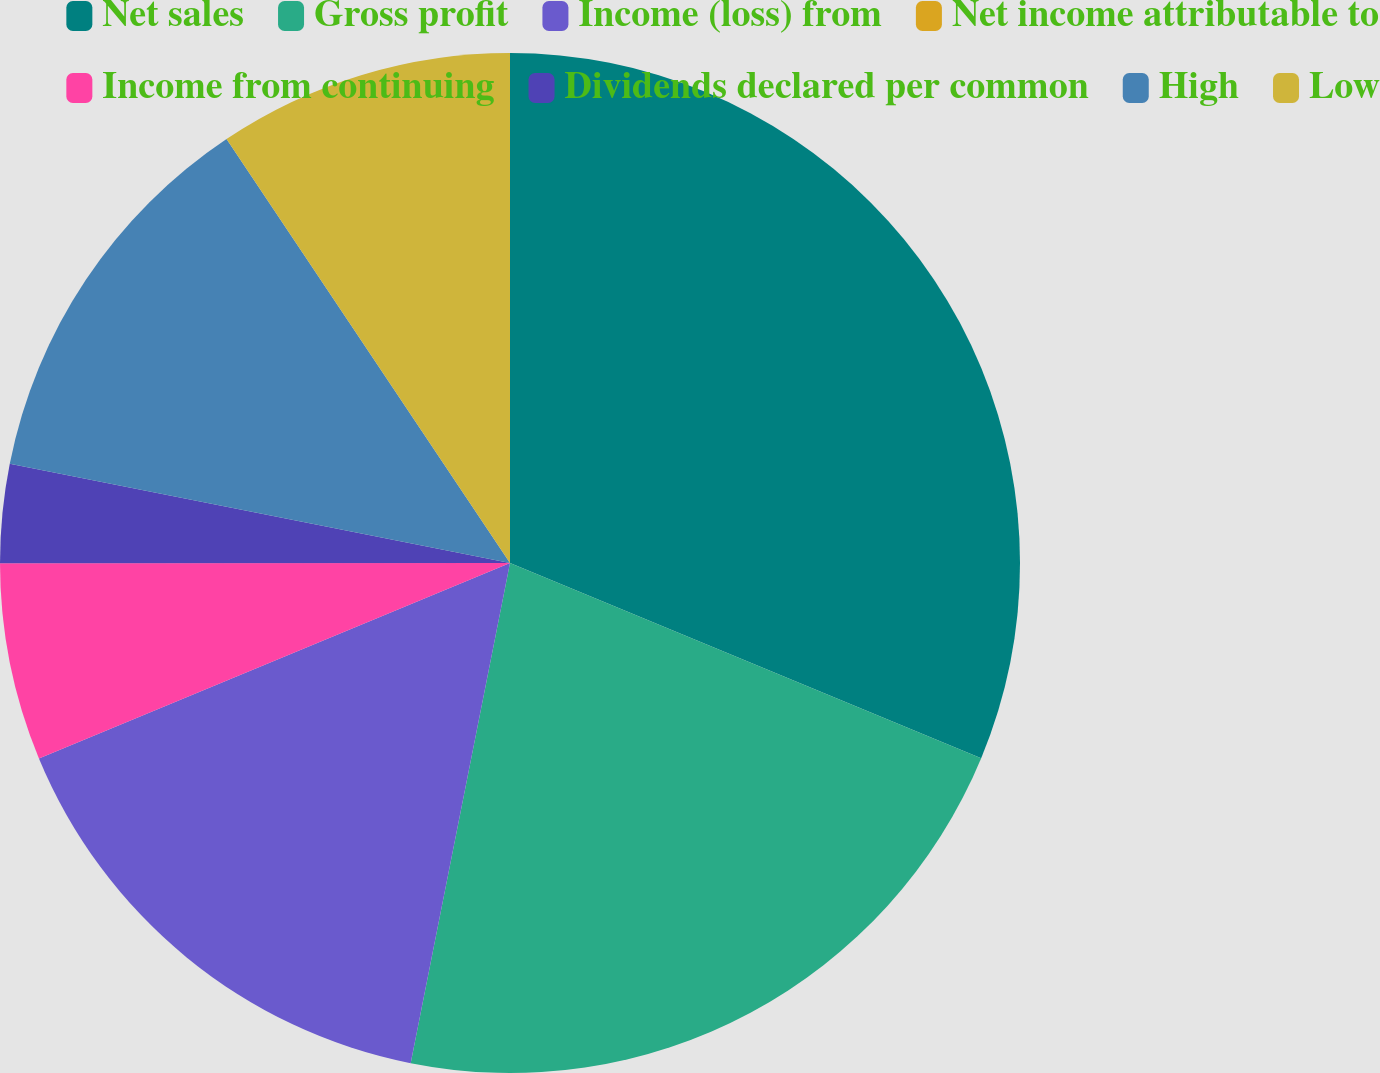Convert chart to OTSL. <chart><loc_0><loc_0><loc_500><loc_500><pie_chart><fcel>Net sales<fcel>Gross profit<fcel>Income (loss) from<fcel>Net income attributable to<fcel>Income from continuing<fcel>Dividends declared per common<fcel>High<fcel>Low<nl><fcel>31.25%<fcel>21.87%<fcel>15.62%<fcel>0.0%<fcel>6.25%<fcel>3.13%<fcel>12.5%<fcel>9.38%<nl></chart> 